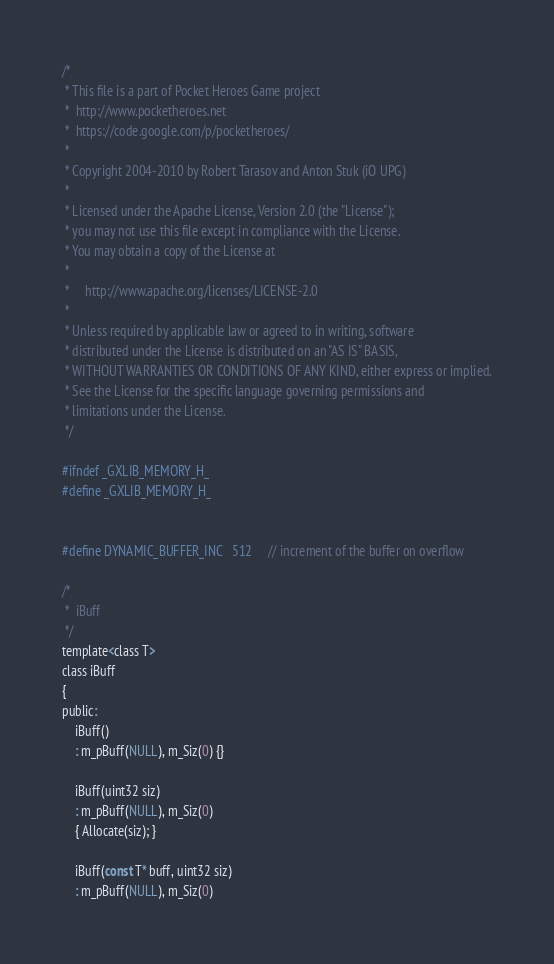Convert code to text. <code><loc_0><loc_0><loc_500><loc_500><_C_>/*
 * This file is a part of Pocket Heroes Game project
 * 	http://www.pocketheroes.net
 *	https://code.google.com/p/pocketheroes/
 *
 * Copyright 2004-2010 by Robert Tarasov and Anton Stuk (iO UPG)
 *
 * Licensed under the Apache License, Version 2.0 (the "License");
 * you may not use this file except in compliance with the License.
 * You may obtain a copy of the License at
 *
 *     http://www.apache.org/licenses/LICENSE-2.0
 *
 * Unless required by applicable law or agreed to in writing, software
 * distributed under the License is distributed on an "AS IS" BASIS,
 * WITHOUT WARRANTIES OR CONDITIONS OF ANY KIND, either express or implied.
 * See the License for the specific language governing permissions and
 * limitations under the License.
 */ 

#ifndef _GXLIB_MEMORY_H_
#define _GXLIB_MEMORY_H_


#define DYNAMIC_BUFFER_INC	512		// increment of the buffer on overflow

/*
 *	iBuff
 */
template<class T>
class iBuff
{
public:
	iBuff()
	: m_pBuff(NULL), m_Siz(0) {}

	iBuff(uint32 siz)
	: m_pBuff(NULL), m_Siz(0)
	{ Allocate(siz); }

	iBuff(const T* buff, uint32 siz)
	: m_pBuff(NULL), m_Siz(0)</code> 